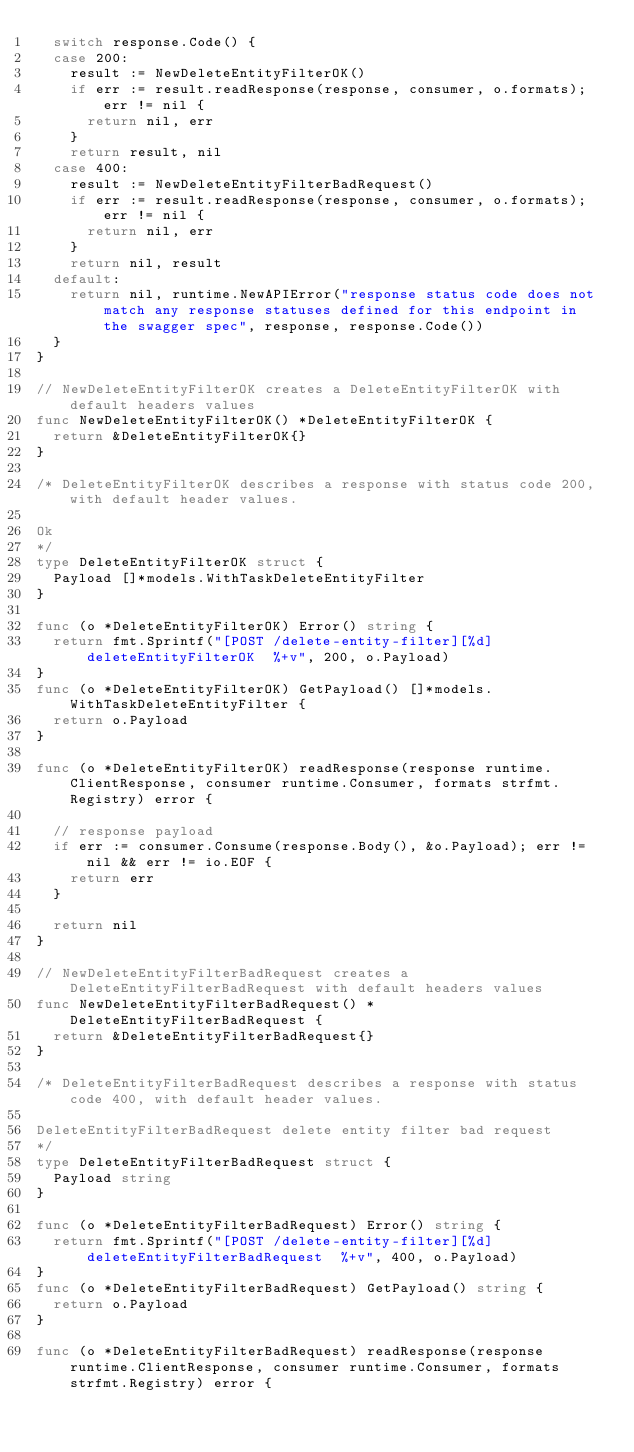<code> <loc_0><loc_0><loc_500><loc_500><_Go_>	switch response.Code() {
	case 200:
		result := NewDeleteEntityFilterOK()
		if err := result.readResponse(response, consumer, o.formats); err != nil {
			return nil, err
		}
		return result, nil
	case 400:
		result := NewDeleteEntityFilterBadRequest()
		if err := result.readResponse(response, consumer, o.formats); err != nil {
			return nil, err
		}
		return nil, result
	default:
		return nil, runtime.NewAPIError("response status code does not match any response statuses defined for this endpoint in the swagger spec", response, response.Code())
	}
}

// NewDeleteEntityFilterOK creates a DeleteEntityFilterOK with default headers values
func NewDeleteEntityFilterOK() *DeleteEntityFilterOK {
	return &DeleteEntityFilterOK{}
}

/* DeleteEntityFilterOK describes a response with status code 200, with default header values.

Ok
*/
type DeleteEntityFilterOK struct {
	Payload []*models.WithTaskDeleteEntityFilter
}

func (o *DeleteEntityFilterOK) Error() string {
	return fmt.Sprintf("[POST /delete-entity-filter][%d] deleteEntityFilterOK  %+v", 200, o.Payload)
}
func (o *DeleteEntityFilterOK) GetPayload() []*models.WithTaskDeleteEntityFilter {
	return o.Payload
}

func (o *DeleteEntityFilterOK) readResponse(response runtime.ClientResponse, consumer runtime.Consumer, formats strfmt.Registry) error {

	// response payload
	if err := consumer.Consume(response.Body(), &o.Payload); err != nil && err != io.EOF {
		return err
	}

	return nil
}

// NewDeleteEntityFilterBadRequest creates a DeleteEntityFilterBadRequest with default headers values
func NewDeleteEntityFilterBadRequest() *DeleteEntityFilterBadRequest {
	return &DeleteEntityFilterBadRequest{}
}

/* DeleteEntityFilterBadRequest describes a response with status code 400, with default header values.

DeleteEntityFilterBadRequest delete entity filter bad request
*/
type DeleteEntityFilterBadRequest struct {
	Payload string
}

func (o *DeleteEntityFilterBadRequest) Error() string {
	return fmt.Sprintf("[POST /delete-entity-filter][%d] deleteEntityFilterBadRequest  %+v", 400, o.Payload)
}
func (o *DeleteEntityFilterBadRequest) GetPayload() string {
	return o.Payload
}

func (o *DeleteEntityFilterBadRequest) readResponse(response runtime.ClientResponse, consumer runtime.Consumer, formats strfmt.Registry) error {
</code> 